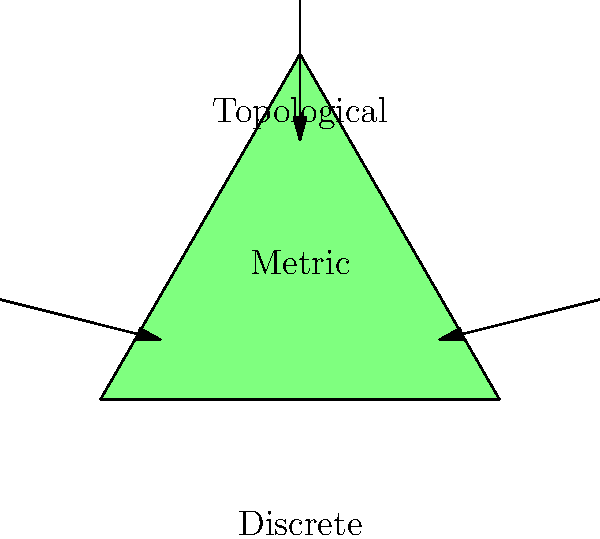In the context of data organization for literary research, which type of topological space would be most suitable for representing the interconnectedness of themes across different works, and why? To answer this question, let's consider the characteristics of each topological space represented in the diagram:

1. Discrete space:
   - Represented by individual points
   - No inherent connection between elements
   - Suitable for categorical data with no natural ordering

2. Metric space:
   - Represented by the circle
   - Has a notion of distance between elements
   - Suitable for quantitative data where similarity can be measured

3. Topological space:
   - Represented by the triangle
   - Preserves connectedness and continuity
   - Allows for more flexible relationships between elements

For representing the interconnectedness of themes across different works:

1. Themes often have complex relationships that can't be easily quantified.
2. Themes may be connected in various ways, not just through simple distances.
3. The relationships between themes can be continuous and multi-dimensional.

Given these considerations, a topological space would be most suitable because:

a) It can represent complex relationships without requiring a specific metric.
b) It allows for the preservation of connectedness, which is crucial for showing how themes relate to each other across works.
c) It provides flexibility in representing various types of relationships, including hierarchical, networked, or overlapping themes.
d) It can accommodate the continuous nature of thematic development across literature.

For a writer using technology for research, a topological representation could be implemented using tools like graph databases or network visualization software, allowing for a rich exploration of thematic connections in literature.
Answer: Topological space 